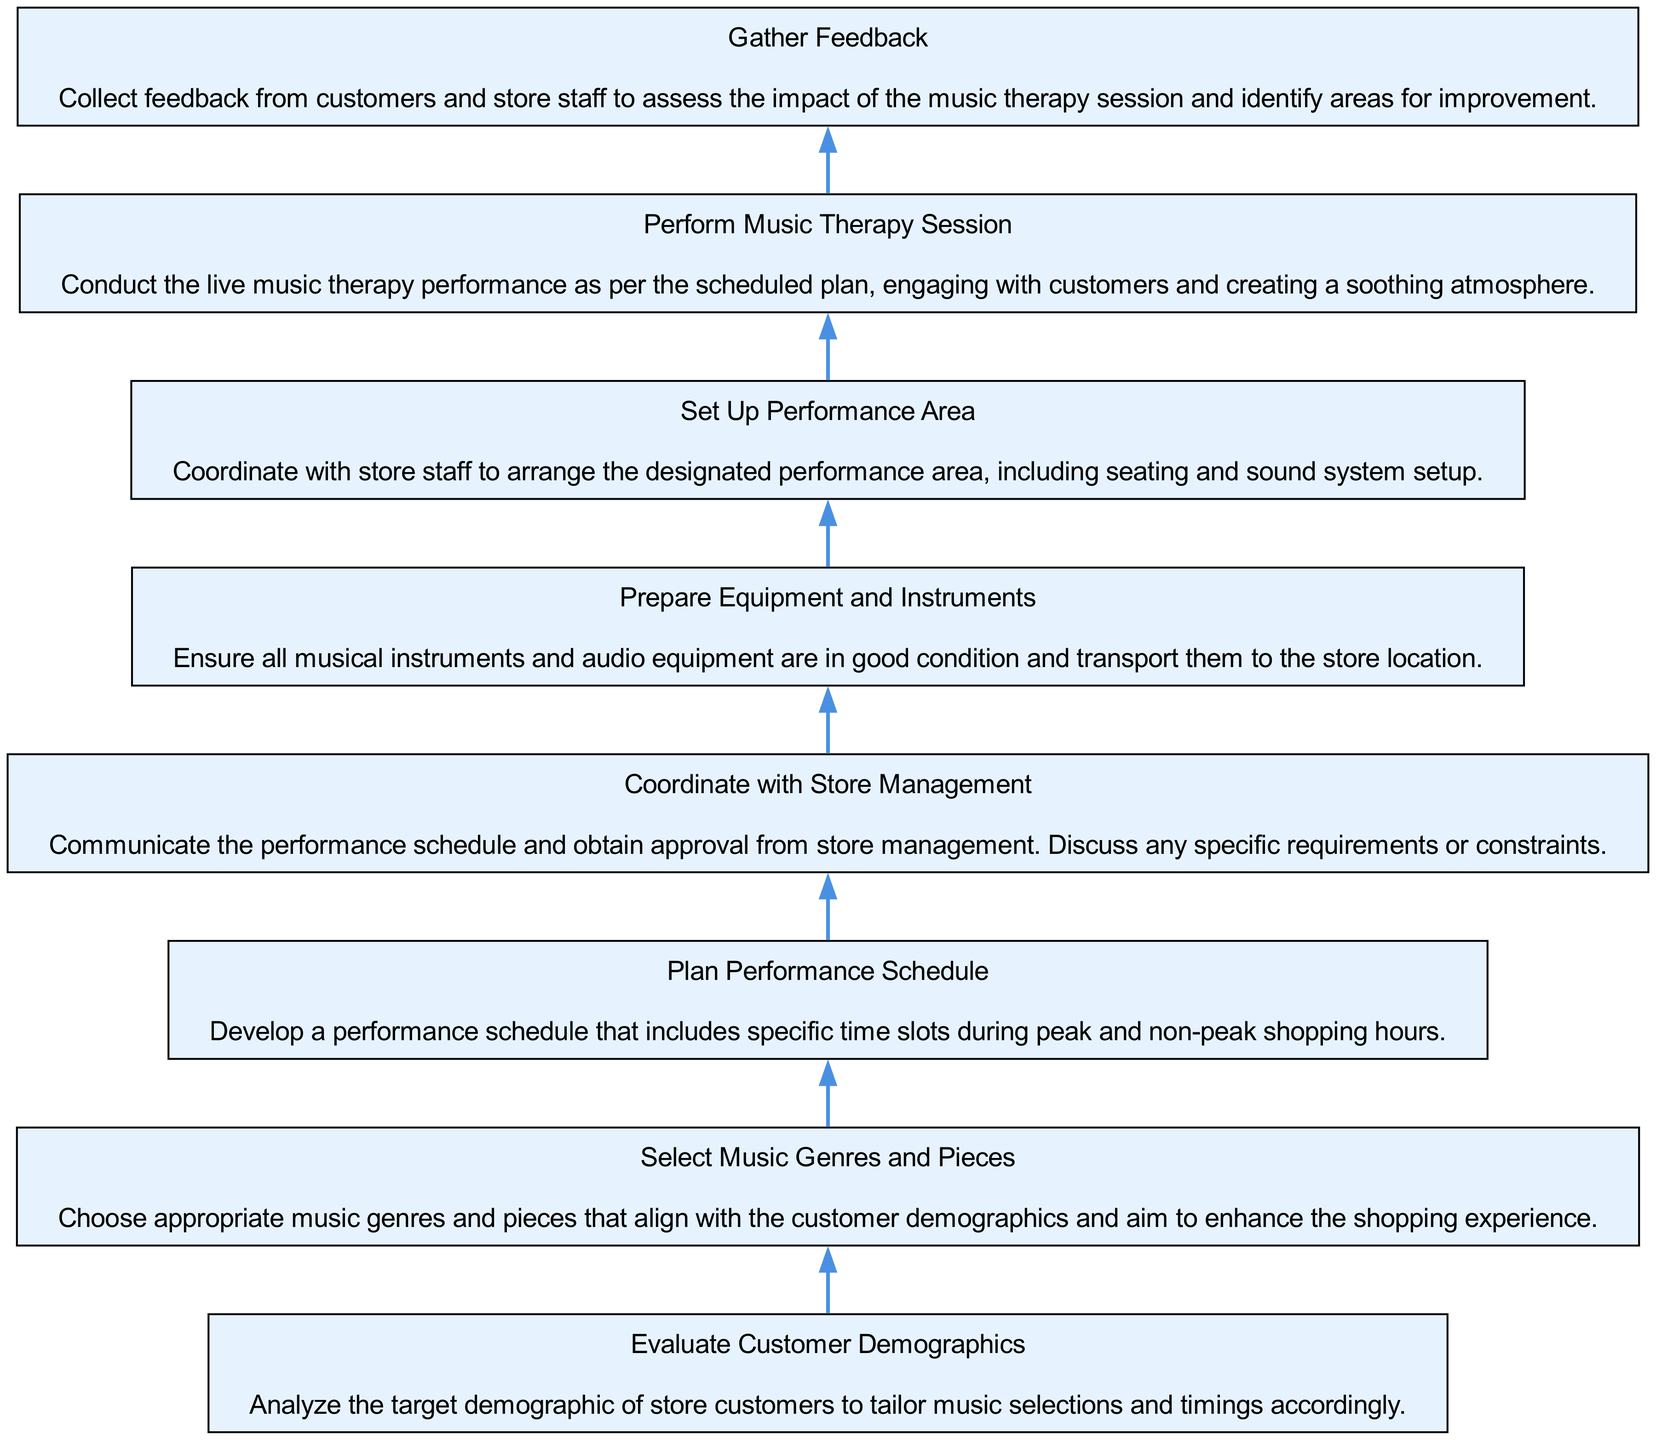What is the first step in coordinating music therapy events? The first step is "Evaluate Customer Demographics," which involves analyzing the target demographic of store customers to tailor music selections and timings accordingly.
Answer: Evaluate Customer Demographics How many total steps are in the flow chart? There are eight steps in total, as represented by eight distinct nodes in the flow of the diagram.
Answer: Eight What comes after selecting music genres and pieces? The next step after "Select Music Genres and Pieces" is "Plan Performance Schedule," indicating the sequence of activities in coordinating the events.
Answer: Plan Performance Schedule Which node involves team collaboration with store staff? The node "Set Up Performance Area" involves collaboration with store staff to arrange the designated performance area, including seating and sound system setup.
Answer: Set Up Performance Area What is the last action taken in the flow chart? The last action is "Gather Feedback," which indicates the importance of collecting feedback from customers and store staff after the performance to assess its impact and identify improvement areas.
Answer: Gather Feedback What is the relationship between "Coordinate with Store Management" and "Plan Performance Schedule"? "Coordinate with Store Management" occurs after "Plan Performance Schedule," indicating that once the schedule is made, it must be communicated and approved by store management.
Answer: Coordinate with Store Management comes after Plan Performance Schedule Which step directly leads to performing the music therapy session? The step that directly leads to "Perform Music Therapy Session" is "Prepare Equipment and Instruments," indicating the preparation required before the actual performance.
Answer: Prepare Equipment and Instruments What action follows the performance of the music therapy session? The action that follows the performance is "Gather Feedback," which is essential for evaluating the success of the event.
Answer: Gather Feedback 